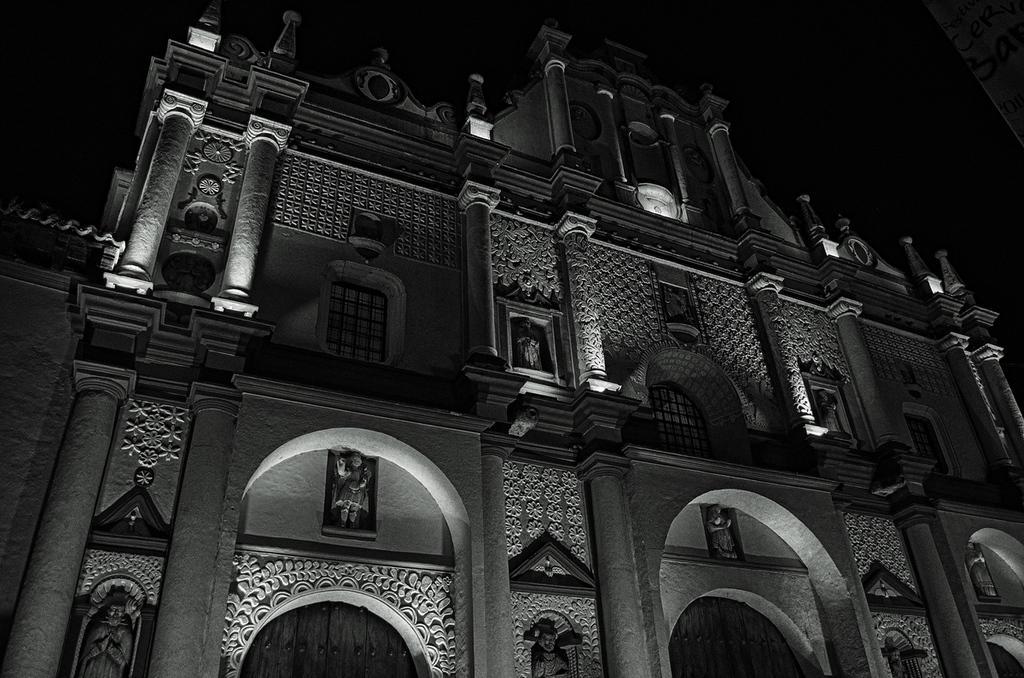How would you summarize this image in a sentence or two? Here in this picture we can see a building present over there and we can see some statues present on it over there. 